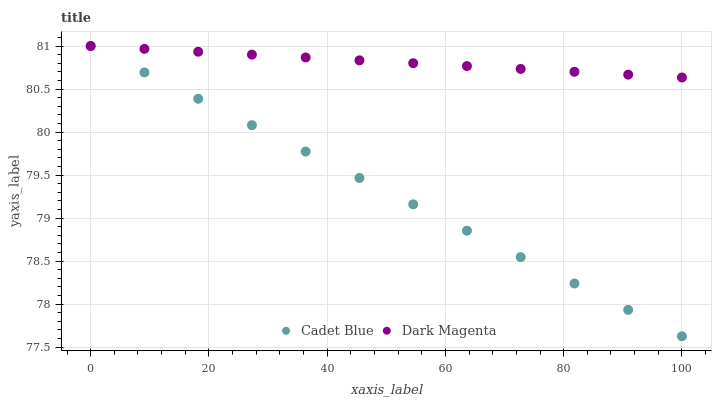Does Cadet Blue have the minimum area under the curve?
Answer yes or no. Yes. Does Dark Magenta have the maximum area under the curve?
Answer yes or no. Yes. Does Dark Magenta have the minimum area under the curve?
Answer yes or no. No. Is Cadet Blue the smoothest?
Answer yes or no. Yes. Is Dark Magenta the roughest?
Answer yes or no. Yes. Is Dark Magenta the smoothest?
Answer yes or no. No. Does Cadet Blue have the lowest value?
Answer yes or no. Yes. Does Dark Magenta have the lowest value?
Answer yes or no. No. Does Dark Magenta have the highest value?
Answer yes or no. Yes. Does Cadet Blue intersect Dark Magenta?
Answer yes or no. Yes. Is Cadet Blue less than Dark Magenta?
Answer yes or no. No. Is Cadet Blue greater than Dark Magenta?
Answer yes or no. No. 